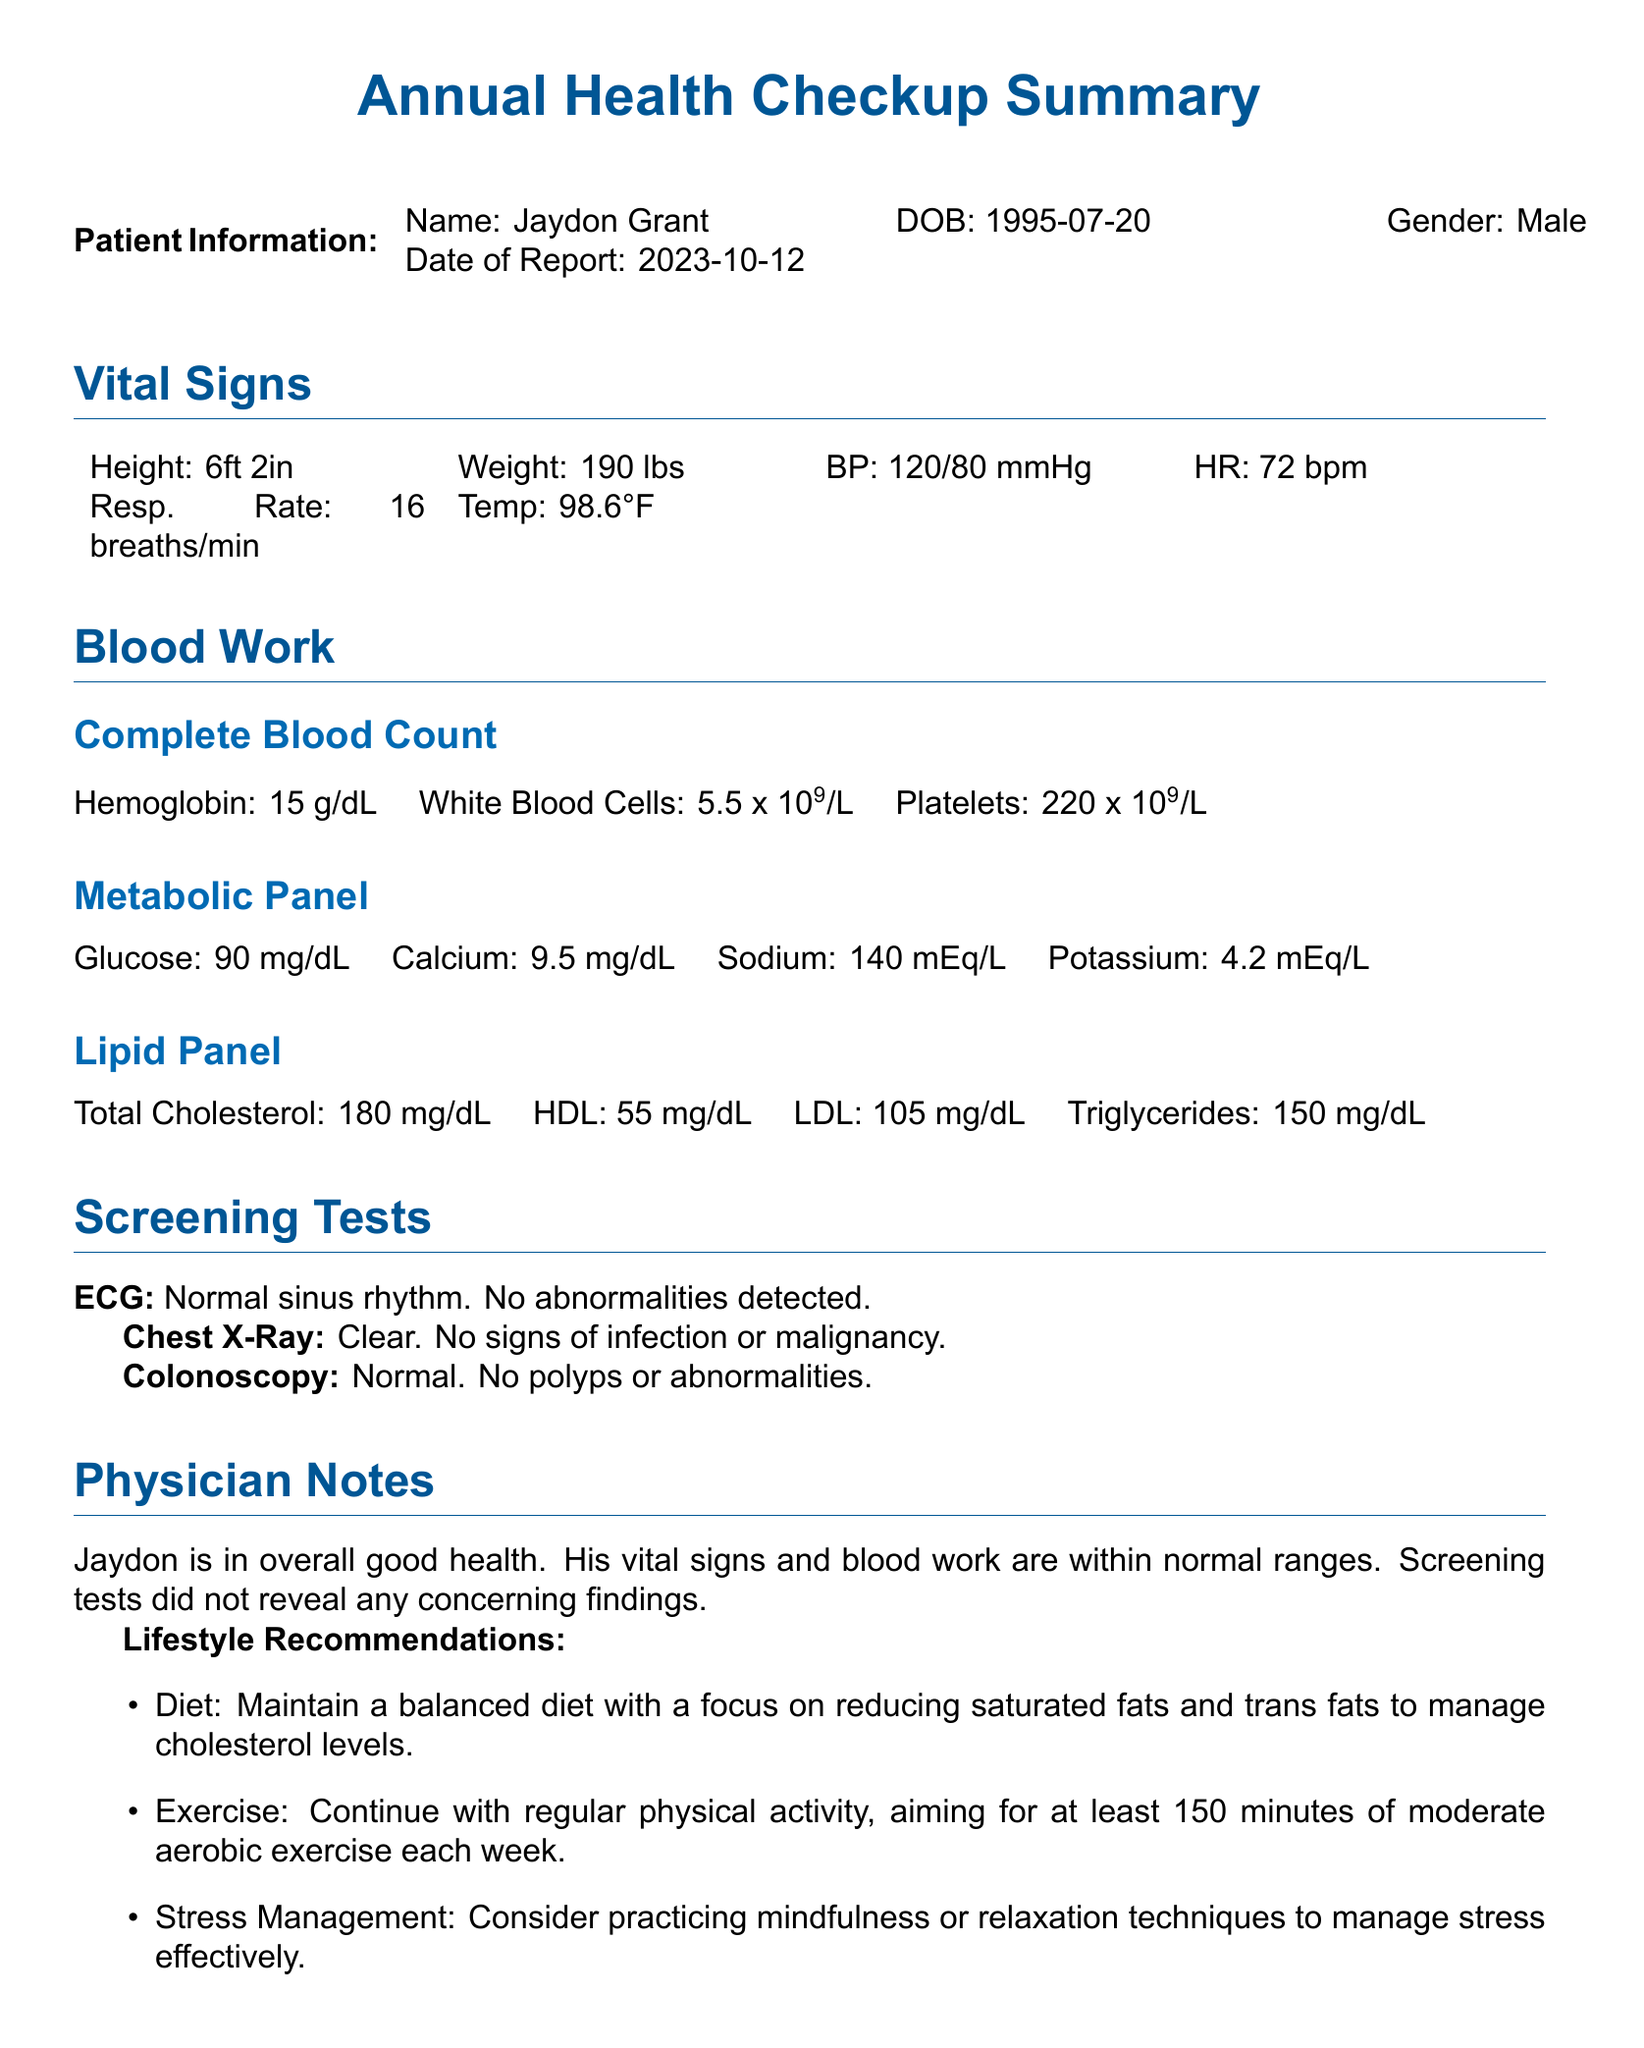what is the name of the patient? The name of the patient is explicitly stated in the document under Patient Information.
Answer: Jaydon Grant what is the date of the report? The date of the report is mentioned in the Patient Information section.
Answer: 2023-10-12 what is the height of the patient? The height is provided in the Vital Signs section, detailing physical measurements.
Answer: 6ft 2in what is the LDL cholesterol level? The LDL level is mentioned in the Lipid Panel subsection, detailing specific blood work results.
Answer: 105 mg/dL what were the results of the ECG? The result of the ECG is summarized in the Screening Tests section, reporting the condition of the heart rhythm.
Answer: Normal sinus rhythm. No abnormalities detected what are the lifestyle recommendations provided? The lifestyle recommendations can be found in the Physician Notes section, outlining health suggestions.
Answer: Maintain a balanced diet, Continue with regular physical activity, Consider practicing mindfulness how many minutes of exercise does the physician recommend weekly? The recommendation for exercise time can be found in the Lifestyle Recommendations section.
Answer: 150 minutes who is the physician? The physician's name is provided at the end of the document, indicating the responsible medical professional.
Answer: Dr. Emily Harding, MD what is the follow-up recommendation? The follow-up recommendation is outlined in the Physician Notes, detailing when the patient should return.
Answer: A follow-up appointment is recommended in one year or sooner if any new symptoms arise 